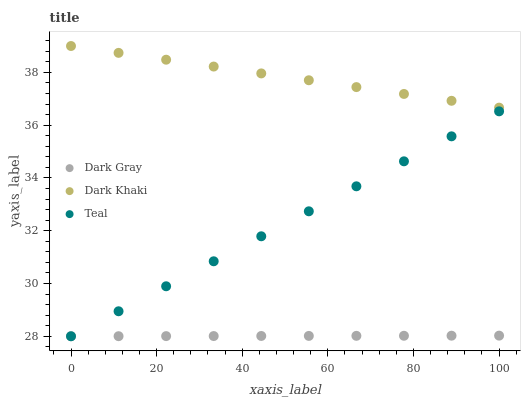Does Dark Gray have the minimum area under the curve?
Answer yes or no. Yes. Does Dark Khaki have the maximum area under the curve?
Answer yes or no. Yes. Does Teal have the minimum area under the curve?
Answer yes or no. No. Does Teal have the maximum area under the curve?
Answer yes or no. No. Is Dark Khaki the smoothest?
Answer yes or no. Yes. Is Teal the roughest?
Answer yes or no. Yes. Is Teal the smoothest?
Answer yes or no. No. Is Dark Khaki the roughest?
Answer yes or no. No. Does Dark Gray have the lowest value?
Answer yes or no. Yes. Does Dark Khaki have the lowest value?
Answer yes or no. No. Does Dark Khaki have the highest value?
Answer yes or no. Yes. Does Teal have the highest value?
Answer yes or no. No. Is Dark Gray less than Dark Khaki?
Answer yes or no. Yes. Is Dark Khaki greater than Dark Gray?
Answer yes or no. Yes. Does Dark Gray intersect Teal?
Answer yes or no. Yes. Is Dark Gray less than Teal?
Answer yes or no. No. Is Dark Gray greater than Teal?
Answer yes or no. No. Does Dark Gray intersect Dark Khaki?
Answer yes or no. No. 